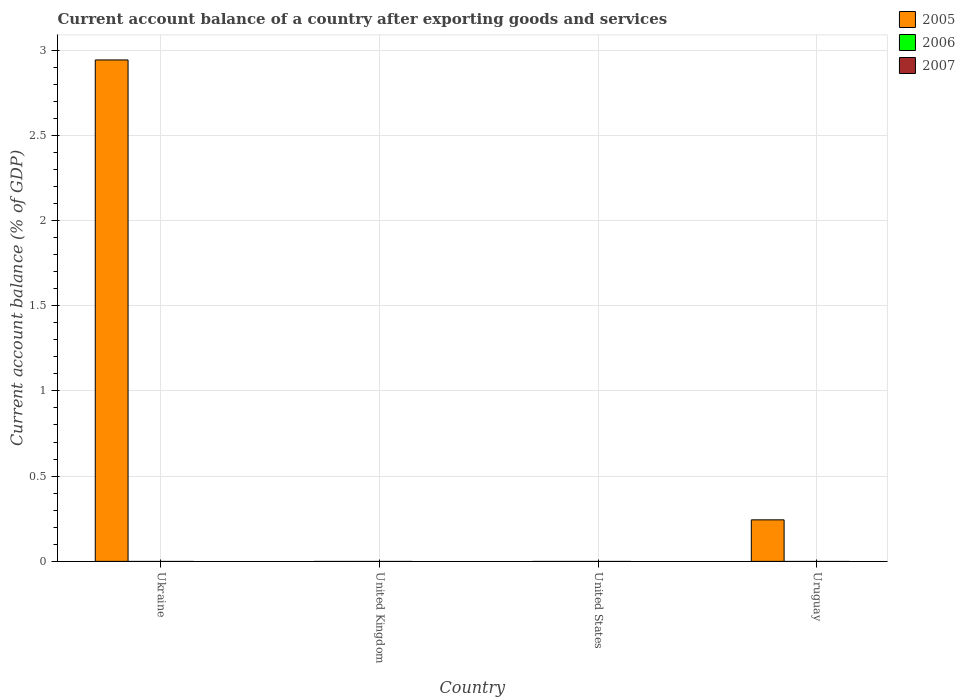How many different coloured bars are there?
Provide a succinct answer. 1. How many bars are there on the 3rd tick from the left?
Provide a short and direct response. 0. What is the label of the 2nd group of bars from the left?
Offer a very short reply. United Kingdom. In how many cases, is the number of bars for a given country not equal to the number of legend labels?
Your response must be concise. 4. Across all countries, what is the maximum account balance in 2005?
Offer a terse response. 2.94. Across all countries, what is the minimum account balance in 2007?
Make the answer very short. 0. In which country was the account balance in 2005 maximum?
Make the answer very short. Ukraine. What is the total account balance in 2005 in the graph?
Your answer should be compact. 3.19. What is the difference between the account balance in 2006 in United Kingdom and the account balance in 2005 in Ukraine?
Offer a terse response. -2.94. What is the average account balance in 2007 per country?
Your answer should be compact. 0. In how many countries, is the account balance in 2006 greater than 2.4 %?
Offer a terse response. 0. What is the difference between the highest and the lowest account balance in 2005?
Your response must be concise. 2.94. Are all the bars in the graph horizontal?
Your answer should be compact. No. How many countries are there in the graph?
Ensure brevity in your answer.  4. What is the difference between two consecutive major ticks on the Y-axis?
Offer a terse response. 0.5. Are the values on the major ticks of Y-axis written in scientific E-notation?
Your response must be concise. No. Does the graph contain any zero values?
Your answer should be compact. Yes. How are the legend labels stacked?
Give a very brief answer. Vertical. What is the title of the graph?
Your response must be concise. Current account balance of a country after exporting goods and services. What is the label or title of the Y-axis?
Your answer should be compact. Current account balance (% of GDP). What is the Current account balance (% of GDP) in 2005 in Ukraine?
Offer a very short reply. 2.94. What is the Current account balance (% of GDP) in 2005 in United Kingdom?
Ensure brevity in your answer.  0. What is the Current account balance (% of GDP) in 2005 in United States?
Give a very brief answer. 0. What is the Current account balance (% of GDP) of 2006 in United States?
Make the answer very short. 0. What is the Current account balance (% of GDP) in 2007 in United States?
Your answer should be compact. 0. What is the Current account balance (% of GDP) of 2005 in Uruguay?
Your answer should be very brief. 0.24. What is the Current account balance (% of GDP) of 2007 in Uruguay?
Give a very brief answer. 0. Across all countries, what is the maximum Current account balance (% of GDP) in 2005?
Provide a short and direct response. 2.94. What is the total Current account balance (% of GDP) of 2005 in the graph?
Offer a terse response. 3.19. What is the difference between the Current account balance (% of GDP) in 2005 in Ukraine and that in Uruguay?
Provide a succinct answer. 2.7. What is the average Current account balance (% of GDP) of 2005 per country?
Your answer should be very brief. 0.8. What is the average Current account balance (% of GDP) of 2006 per country?
Provide a short and direct response. 0. What is the average Current account balance (% of GDP) of 2007 per country?
Your answer should be very brief. 0. What is the ratio of the Current account balance (% of GDP) of 2005 in Ukraine to that in Uruguay?
Make the answer very short. 12.08. What is the difference between the highest and the lowest Current account balance (% of GDP) of 2005?
Offer a very short reply. 2.94. 